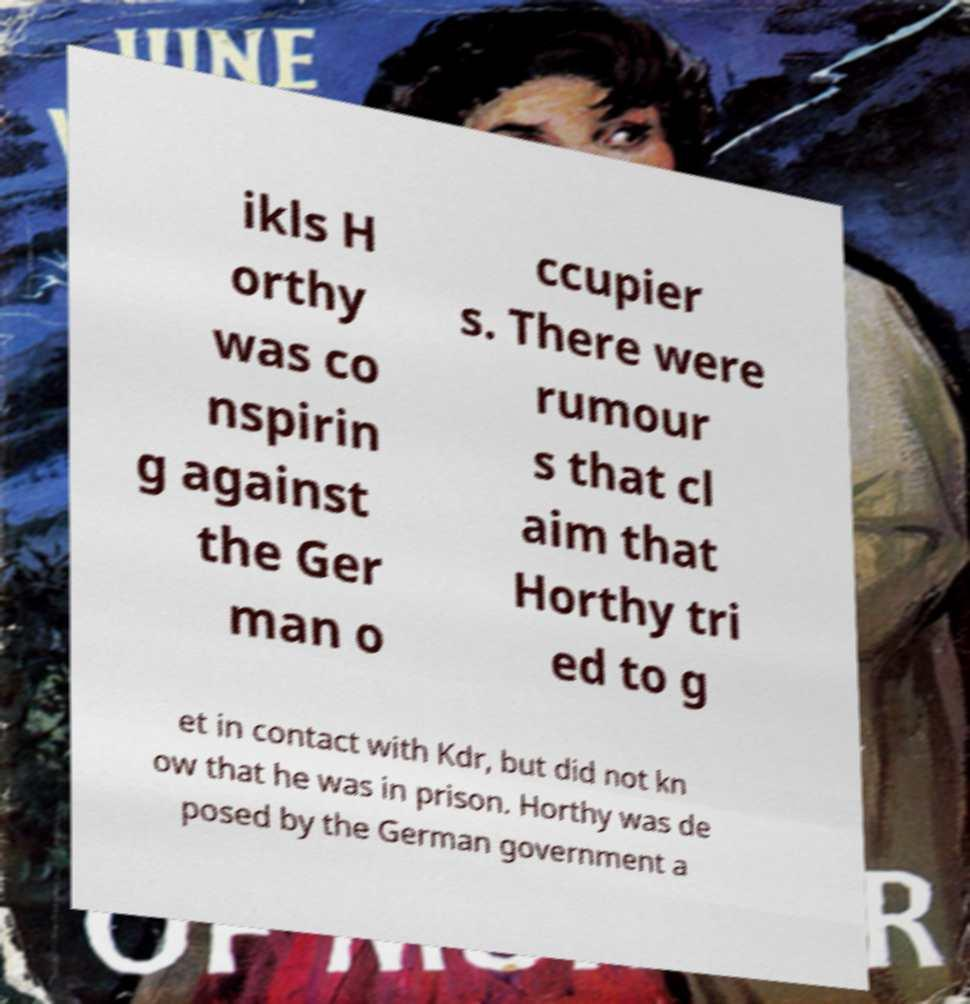Can you accurately transcribe the text from the provided image for me? ikls H orthy was co nspirin g against the Ger man o ccupier s. There were rumour s that cl aim that Horthy tri ed to g et in contact with Kdr, but did not kn ow that he was in prison. Horthy was de posed by the German government a 